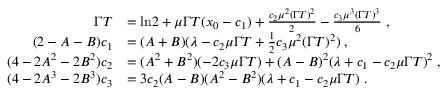<formula> <loc_0><loc_0><loc_500><loc_500>\begin{array} { r l } { \Gamma T } & { = \ln \, 2 + \mu \Gamma T ( x _ { 0 } - c _ { 1 } ) + \frac { c _ { 2 } \mu ^ { 2 } ( \Gamma T ) ^ { 2 } } { 2 } - \frac { c _ { 3 } \mu ^ { 3 } ( \Gamma T ) ^ { 3 } } { 6 } \, , } \\ { ( 2 - A - B ) c _ { 1 } } & { = ( A + B ) ( \lambda - c _ { 2 } \mu \Gamma T + \frac { 1 } { 2 } c _ { 3 } \mu ^ { 2 } ( \Gamma T ) ^ { 2 } ) \, , } \\ { ( 4 - 2 A ^ { 2 } - 2 B ^ { 2 } ) c _ { 2 } } & { = ( A ^ { 2 } + B ^ { 2 } ) ( - 2 c _ { 3 } \mu \Gamma T ) + ( A - B ) ^ { 2 } ( \lambda + c _ { 1 } - c _ { 2 } \mu \Gamma T ) ^ { 2 } \, , } \\ { ( 4 - 2 A ^ { 3 } - 2 B ^ { 3 } ) c _ { 3 } } & { = 3 c _ { 2 } ( A - B ) ( A ^ { 2 } - B ^ { 2 } ) ( \lambda + c _ { 1 } - c _ { 2 } \mu \Gamma T ) \, . } \end{array}</formula> 